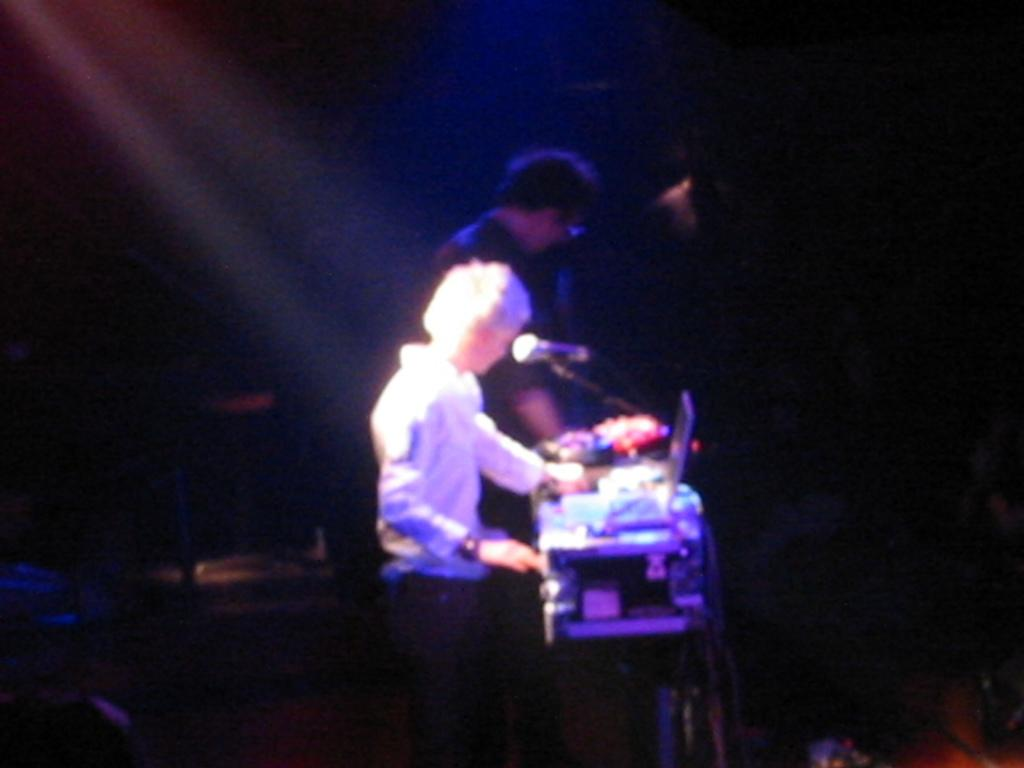How many people are present in the image? There are two people in the image. What object is in front of one of the people? There is a laptop in front of one of the people. What device is visible in the image that is typically used for amplifying sound? There is a microphone (mic) in the image. What can be said about the background of the image? The background of the image is dark. What type of curtain can be seen hanging from the ceiling in the image? There is no curtain present in the image. What dish is being served on the plate in the image? There is no plate present in the image. What celestial object can be seen shining brightly in the image? There is no star visible in the image. 